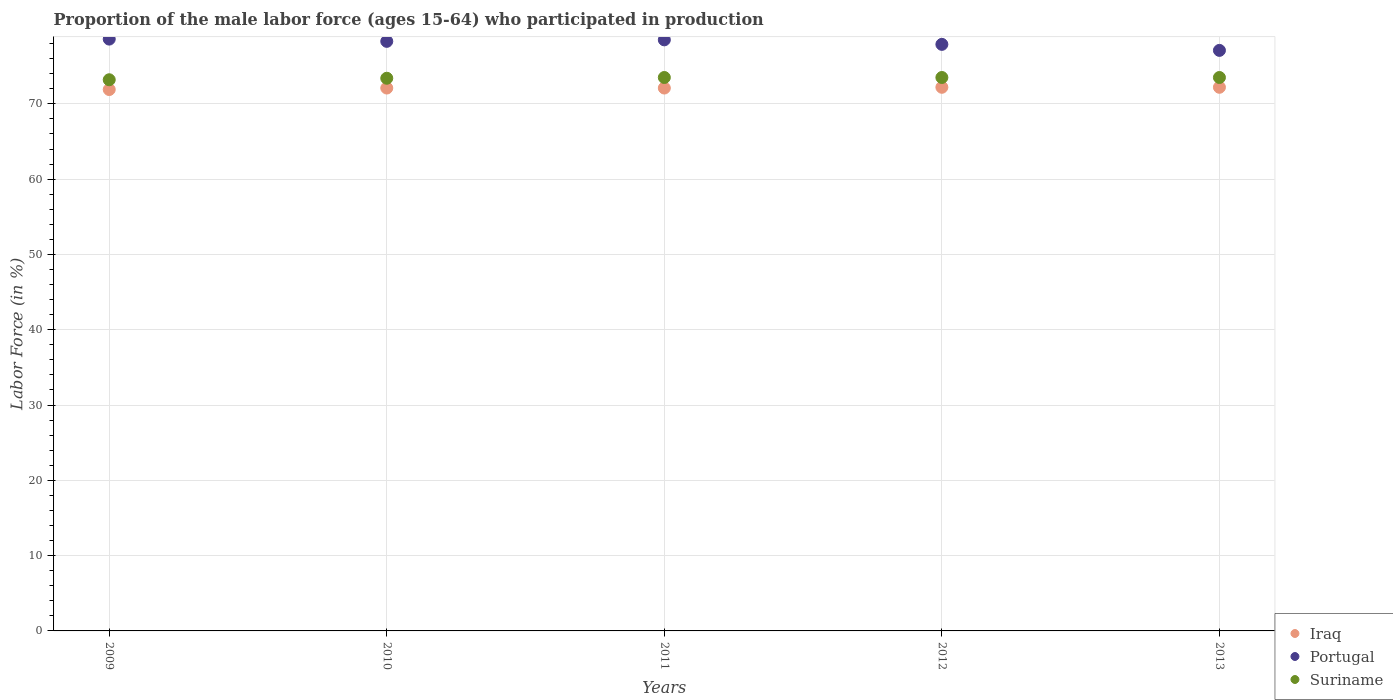How many different coloured dotlines are there?
Your response must be concise. 3. What is the proportion of the male labor force who participated in production in Portugal in 2011?
Your answer should be very brief. 78.5. Across all years, what is the maximum proportion of the male labor force who participated in production in Portugal?
Keep it short and to the point. 78.6. Across all years, what is the minimum proportion of the male labor force who participated in production in Iraq?
Provide a short and direct response. 71.9. In which year was the proportion of the male labor force who participated in production in Portugal maximum?
Give a very brief answer. 2009. What is the total proportion of the male labor force who participated in production in Portugal in the graph?
Make the answer very short. 390.4. What is the difference between the proportion of the male labor force who participated in production in Iraq in 2009 and that in 2012?
Offer a very short reply. -0.3. What is the difference between the proportion of the male labor force who participated in production in Iraq in 2011 and the proportion of the male labor force who participated in production in Portugal in 2013?
Offer a very short reply. -5. What is the average proportion of the male labor force who participated in production in Suriname per year?
Offer a terse response. 73.42. In the year 2012, what is the difference between the proportion of the male labor force who participated in production in Portugal and proportion of the male labor force who participated in production in Iraq?
Your response must be concise. 5.7. In how many years, is the proportion of the male labor force who participated in production in Portugal greater than 24 %?
Ensure brevity in your answer.  5. What is the ratio of the proportion of the male labor force who participated in production in Portugal in 2012 to that in 2013?
Your response must be concise. 1.01. Is the proportion of the male labor force who participated in production in Iraq in 2010 less than that in 2011?
Make the answer very short. No. Is the difference between the proportion of the male labor force who participated in production in Portugal in 2009 and 2013 greater than the difference between the proportion of the male labor force who participated in production in Iraq in 2009 and 2013?
Offer a very short reply. Yes. What is the difference between the highest and the second highest proportion of the male labor force who participated in production in Suriname?
Your answer should be very brief. 0. What is the difference between the highest and the lowest proportion of the male labor force who participated in production in Suriname?
Your answer should be compact. 0.3. Is the sum of the proportion of the male labor force who participated in production in Suriname in 2012 and 2013 greater than the maximum proportion of the male labor force who participated in production in Iraq across all years?
Provide a succinct answer. Yes. Is it the case that in every year, the sum of the proportion of the male labor force who participated in production in Suriname and proportion of the male labor force who participated in production in Iraq  is greater than the proportion of the male labor force who participated in production in Portugal?
Your answer should be compact. Yes. Does the proportion of the male labor force who participated in production in Portugal monotonically increase over the years?
Provide a succinct answer. No. Is the proportion of the male labor force who participated in production in Iraq strictly less than the proportion of the male labor force who participated in production in Portugal over the years?
Make the answer very short. Yes. How many dotlines are there?
Keep it short and to the point. 3. How many years are there in the graph?
Provide a succinct answer. 5. What is the difference between two consecutive major ticks on the Y-axis?
Ensure brevity in your answer.  10. Are the values on the major ticks of Y-axis written in scientific E-notation?
Offer a terse response. No. Does the graph contain any zero values?
Your answer should be compact. No. Does the graph contain grids?
Keep it short and to the point. Yes. Where does the legend appear in the graph?
Provide a succinct answer. Bottom right. How many legend labels are there?
Keep it short and to the point. 3. How are the legend labels stacked?
Give a very brief answer. Vertical. What is the title of the graph?
Your response must be concise. Proportion of the male labor force (ages 15-64) who participated in production. Does "Equatorial Guinea" appear as one of the legend labels in the graph?
Offer a very short reply. No. What is the label or title of the X-axis?
Give a very brief answer. Years. What is the Labor Force (in %) of Iraq in 2009?
Your response must be concise. 71.9. What is the Labor Force (in %) of Portugal in 2009?
Your response must be concise. 78.6. What is the Labor Force (in %) of Suriname in 2009?
Your answer should be very brief. 73.2. What is the Labor Force (in %) of Iraq in 2010?
Ensure brevity in your answer.  72.1. What is the Labor Force (in %) in Portugal in 2010?
Keep it short and to the point. 78.3. What is the Labor Force (in %) of Suriname in 2010?
Provide a succinct answer. 73.4. What is the Labor Force (in %) in Iraq in 2011?
Your answer should be compact. 72.1. What is the Labor Force (in %) of Portugal in 2011?
Make the answer very short. 78.5. What is the Labor Force (in %) in Suriname in 2011?
Give a very brief answer. 73.5. What is the Labor Force (in %) of Iraq in 2012?
Make the answer very short. 72.2. What is the Labor Force (in %) of Portugal in 2012?
Your response must be concise. 77.9. What is the Labor Force (in %) of Suriname in 2012?
Your response must be concise. 73.5. What is the Labor Force (in %) of Iraq in 2013?
Ensure brevity in your answer.  72.2. What is the Labor Force (in %) of Portugal in 2013?
Keep it short and to the point. 77.1. What is the Labor Force (in %) of Suriname in 2013?
Your response must be concise. 73.5. Across all years, what is the maximum Labor Force (in %) of Iraq?
Your answer should be very brief. 72.2. Across all years, what is the maximum Labor Force (in %) of Portugal?
Provide a short and direct response. 78.6. Across all years, what is the maximum Labor Force (in %) in Suriname?
Provide a succinct answer. 73.5. Across all years, what is the minimum Labor Force (in %) of Iraq?
Your answer should be compact. 71.9. Across all years, what is the minimum Labor Force (in %) of Portugal?
Offer a terse response. 77.1. Across all years, what is the minimum Labor Force (in %) in Suriname?
Keep it short and to the point. 73.2. What is the total Labor Force (in %) of Iraq in the graph?
Your answer should be compact. 360.5. What is the total Labor Force (in %) in Portugal in the graph?
Make the answer very short. 390.4. What is the total Labor Force (in %) of Suriname in the graph?
Your answer should be compact. 367.1. What is the difference between the Labor Force (in %) of Iraq in 2009 and that in 2011?
Offer a terse response. -0.2. What is the difference between the Labor Force (in %) of Iraq in 2009 and that in 2012?
Your answer should be very brief. -0.3. What is the difference between the Labor Force (in %) in Portugal in 2009 and that in 2012?
Your answer should be very brief. 0.7. What is the difference between the Labor Force (in %) in Suriname in 2009 and that in 2012?
Offer a very short reply. -0.3. What is the difference between the Labor Force (in %) in Portugal in 2009 and that in 2013?
Give a very brief answer. 1.5. What is the difference between the Labor Force (in %) of Suriname in 2009 and that in 2013?
Ensure brevity in your answer.  -0.3. What is the difference between the Labor Force (in %) in Portugal in 2010 and that in 2011?
Your answer should be very brief. -0.2. What is the difference between the Labor Force (in %) in Suriname in 2010 and that in 2011?
Provide a short and direct response. -0.1. What is the difference between the Labor Force (in %) of Suriname in 2010 and that in 2012?
Your response must be concise. -0.1. What is the difference between the Labor Force (in %) of Iraq in 2010 and that in 2013?
Your answer should be compact. -0.1. What is the difference between the Labor Force (in %) of Portugal in 2010 and that in 2013?
Ensure brevity in your answer.  1.2. What is the difference between the Labor Force (in %) of Suriname in 2010 and that in 2013?
Offer a very short reply. -0.1. What is the difference between the Labor Force (in %) in Iraq in 2011 and that in 2012?
Offer a very short reply. -0.1. What is the difference between the Labor Force (in %) in Suriname in 2011 and that in 2012?
Give a very brief answer. 0. What is the difference between the Labor Force (in %) in Portugal in 2012 and that in 2013?
Offer a terse response. 0.8. What is the difference between the Labor Force (in %) in Suriname in 2012 and that in 2013?
Make the answer very short. 0. What is the difference between the Labor Force (in %) in Iraq in 2009 and the Labor Force (in %) in Portugal in 2010?
Give a very brief answer. -6.4. What is the difference between the Labor Force (in %) in Iraq in 2009 and the Labor Force (in %) in Suriname in 2010?
Your response must be concise. -1.5. What is the difference between the Labor Force (in %) of Portugal in 2009 and the Labor Force (in %) of Suriname in 2010?
Provide a short and direct response. 5.2. What is the difference between the Labor Force (in %) of Iraq in 2009 and the Labor Force (in %) of Suriname in 2011?
Provide a succinct answer. -1.6. What is the difference between the Labor Force (in %) in Iraq in 2009 and the Labor Force (in %) in Portugal in 2012?
Offer a terse response. -6. What is the difference between the Labor Force (in %) of Iraq in 2009 and the Labor Force (in %) of Suriname in 2013?
Keep it short and to the point. -1.6. What is the difference between the Labor Force (in %) of Iraq in 2010 and the Labor Force (in %) of Suriname in 2011?
Make the answer very short. -1.4. What is the difference between the Labor Force (in %) in Portugal in 2010 and the Labor Force (in %) in Suriname in 2011?
Your answer should be very brief. 4.8. What is the difference between the Labor Force (in %) in Iraq in 2010 and the Labor Force (in %) in Suriname in 2012?
Provide a short and direct response. -1.4. What is the difference between the Labor Force (in %) of Portugal in 2010 and the Labor Force (in %) of Suriname in 2012?
Your answer should be compact. 4.8. What is the difference between the Labor Force (in %) of Iraq in 2010 and the Labor Force (in %) of Portugal in 2013?
Make the answer very short. -5. What is the difference between the Labor Force (in %) of Portugal in 2010 and the Labor Force (in %) of Suriname in 2013?
Make the answer very short. 4.8. What is the difference between the Labor Force (in %) in Iraq in 2011 and the Labor Force (in %) in Suriname in 2012?
Offer a very short reply. -1.4. What is the difference between the Labor Force (in %) of Portugal in 2011 and the Labor Force (in %) of Suriname in 2012?
Give a very brief answer. 5. What is the difference between the Labor Force (in %) of Iraq in 2011 and the Labor Force (in %) of Portugal in 2013?
Give a very brief answer. -5. What is the difference between the Labor Force (in %) of Iraq in 2011 and the Labor Force (in %) of Suriname in 2013?
Your answer should be very brief. -1.4. What is the difference between the Labor Force (in %) in Portugal in 2011 and the Labor Force (in %) in Suriname in 2013?
Ensure brevity in your answer.  5. What is the difference between the Labor Force (in %) in Iraq in 2012 and the Labor Force (in %) in Suriname in 2013?
Provide a succinct answer. -1.3. What is the difference between the Labor Force (in %) of Portugal in 2012 and the Labor Force (in %) of Suriname in 2013?
Offer a very short reply. 4.4. What is the average Labor Force (in %) in Iraq per year?
Your response must be concise. 72.1. What is the average Labor Force (in %) of Portugal per year?
Offer a terse response. 78.08. What is the average Labor Force (in %) in Suriname per year?
Ensure brevity in your answer.  73.42. In the year 2010, what is the difference between the Labor Force (in %) of Portugal and Labor Force (in %) of Suriname?
Give a very brief answer. 4.9. In the year 2011, what is the difference between the Labor Force (in %) in Iraq and Labor Force (in %) in Suriname?
Keep it short and to the point. -1.4. In the year 2011, what is the difference between the Labor Force (in %) in Portugal and Labor Force (in %) in Suriname?
Keep it short and to the point. 5. In the year 2012, what is the difference between the Labor Force (in %) of Iraq and Labor Force (in %) of Portugal?
Provide a succinct answer. -5.7. In the year 2012, what is the difference between the Labor Force (in %) of Iraq and Labor Force (in %) of Suriname?
Offer a very short reply. -1.3. In the year 2012, what is the difference between the Labor Force (in %) of Portugal and Labor Force (in %) of Suriname?
Provide a short and direct response. 4.4. In the year 2013, what is the difference between the Labor Force (in %) of Iraq and Labor Force (in %) of Portugal?
Your response must be concise. -4.9. In the year 2013, what is the difference between the Labor Force (in %) of Portugal and Labor Force (in %) of Suriname?
Keep it short and to the point. 3.6. What is the ratio of the Labor Force (in %) of Portugal in 2009 to that in 2010?
Your answer should be very brief. 1. What is the ratio of the Labor Force (in %) in Portugal in 2009 to that in 2011?
Give a very brief answer. 1. What is the ratio of the Labor Force (in %) of Iraq in 2009 to that in 2012?
Give a very brief answer. 1. What is the ratio of the Labor Force (in %) of Portugal in 2009 to that in 2012?
Keep it short and to the point. 1.01. What is the ratio of the Labor Force (in %) of Suriname in 2009 to that in 2012?
Give a very brief answer. 1. What is the ratio of the Labor Force (in %) in Iraq in 2009 to that in 2013?
Your response must be concise. 1. What is the ratio of the Labor Force (in %) in Portugal in 2009 to that in 2013?
Ensure brevity in your answer.  1.02. What is the ratio of the Labor Force (in %) of Suriname in 2010 to that in 2011?
Your answer should be very brief. 1. What is the ratio of the Labor Force (in %) in Suriname in 2010 to that in 2012?
Offer a terse response. 1. What is the ratio of the Labor Force (in %) in Iraq in 2010 to that in 2013?
Give a very brief answer. 1. What is the ratio of the Labor Force (in %) of Portugal in 2010 to that in 2013?
Provide a short and direct response. 1.02. What is the ratio of the Labor Force (in %) of Portugal in 2011 to that in 2012?
Provide a short and direct response. 1.01. What is the ratio of the Labor Force (in %) of Suriname in 2011 to that in 2012?
Your answer should be compact. 1. What is the ratio of the Labor Force (in %) in Portugal in 2011 to that in 2013?
Ensure brevity in your answer.  1.02. What is the ratio of the Labor Force (in %) of Iraq in 2012 to that in 2013?
Your answer should be very brief. 1. What is the ratio of the Labor Force (in %) in Portugal in 2012 to that in 2013?
Make the answer very short. 1.01. What is the ratio of the Labor Force (in %) of Suriname in 2012 to that in 2013?
Keep it short and to the point. 1. What is the difference between the highest and the second highest Labor Force (in %) in Iraq?
Ensure brevity in your answer.  0. What is the difference between the highest and the second highest Labor Force (in %) of Portugal?
Ensure brevity in your answer.  0.1. What is the difference between the highest and the lowest Labor Force (in %) of Portugal?
Provide a succinct answer. 1.5. What is the difference between the highest and the lowest Labor Force (in %) of Suriname?
Offer a terse response. 0.3. 